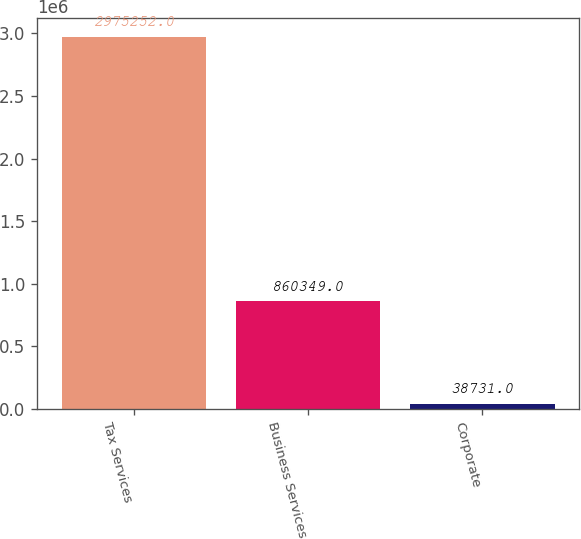Convert chart. <chart><loc_0><loc_0><loc_500><loc_500><bar_chart><fcel>Tax Services<fcel>Business Services<fcel>Corporate<nl><fcel>2.97525e+06<fcel>860349<fcel>38731<nl></chart> 